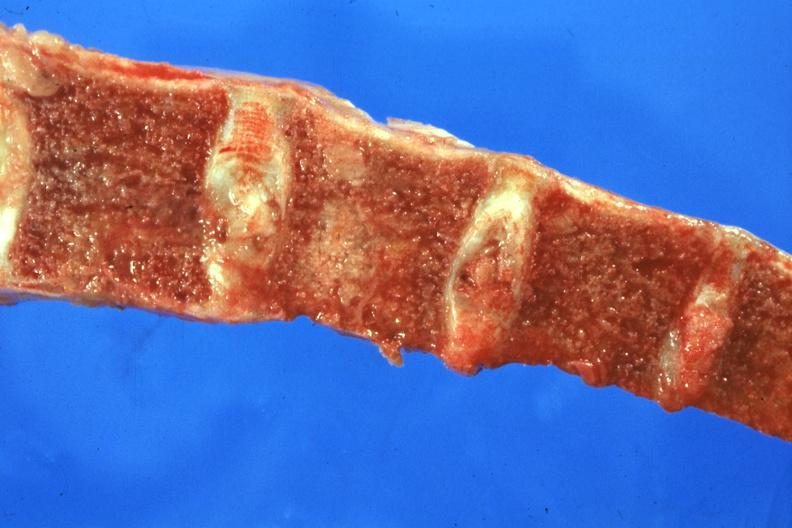s joints present?
Answer the question using a single word or phrase. Yes 